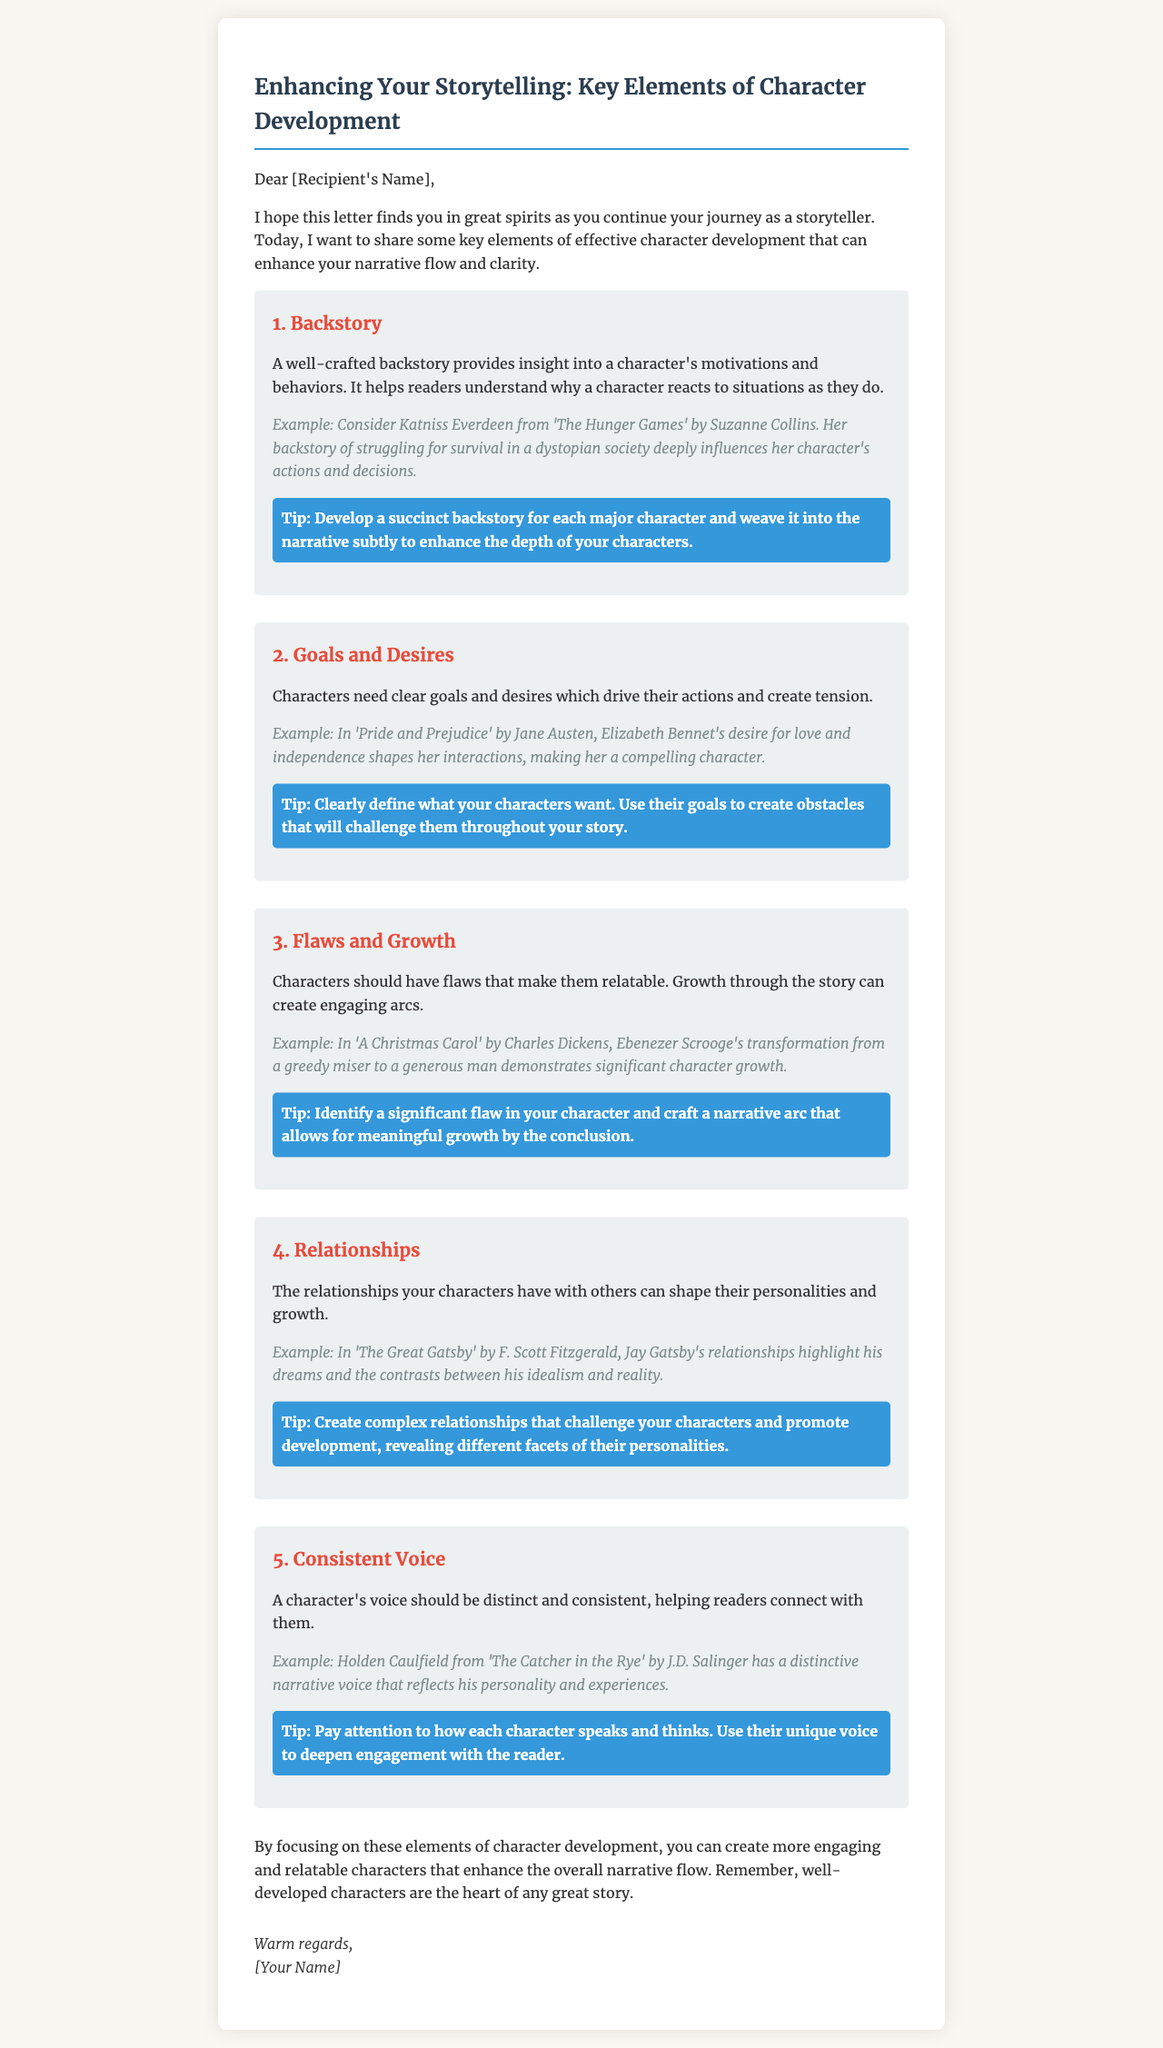What is the title of the letter? The title is stated prominently at the beginning of the document.
Answer: Enhancing Your Storytelling: Key Elements of Character Development Who is the intended recipient of the letter? The recipient's name is mentioned in the salutation format of the letter.
Answer: [Recipient's Name] How many key elements are outlined in the letter? The letter lists multiple elements under separate headings.
Answer: 5 Which character is used as an example for backstory? The document provides a specific character example to illustrate the concept of backstory.
Answer: Katniss Everdeen What common theme is highlighted among all character development elements? Each element emphasizes a particular common aspect relevant to character development.
Answer: Relatability What does the letter suggest as a tip for creating compelling relationships? A specific action is recommended in the tips section of the relationships element.
Answer: Create complex relationships What is the overarching message of the letter regarding character development? The conclusion summarizes the main takeaway from the discussion on character development.
Answer: Well-developed characters are the heart of any great story 